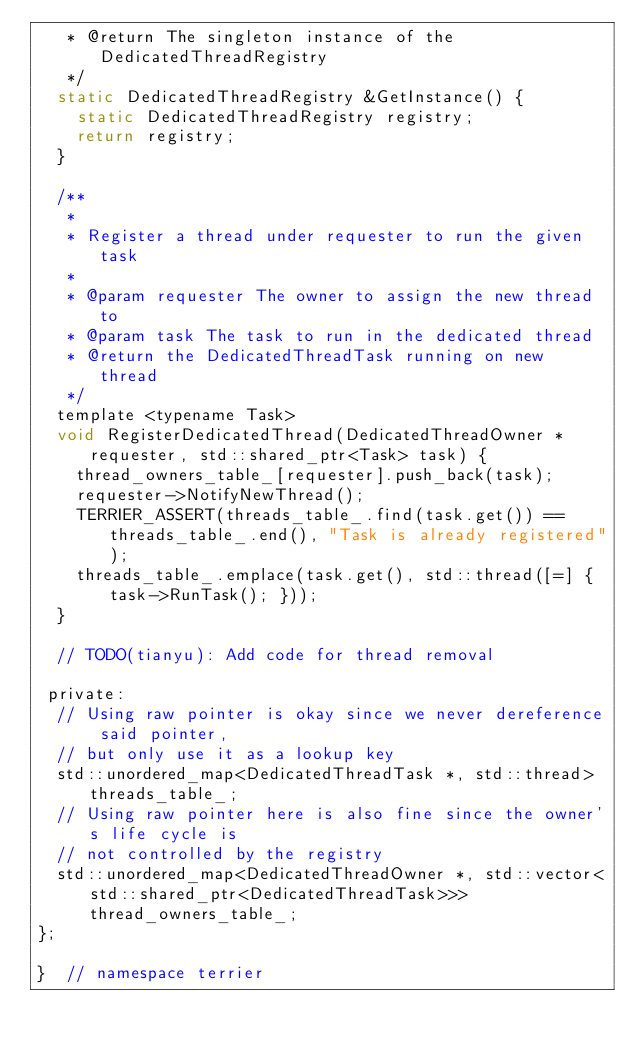Convert code to text. <code><loc_0><loc_0><loc_500><loc_500><_C_>   * @return The singleton instance of the DedicatedThreadRegistry
   */
  static DedicatedThreadRegistry &GetInstance() {
    static DedicatedThreadRegistry registry;
    return registry;
  }

  /**
   *
   * Register a thread under requester to run the given task
   *
   * @param requester The owner to assign the new thread to
   * @param task The task to run in the dedicated thread
   * @return the DedicatedThreadTask running on new thread
   */
  template <typename Task>
  void RegisterDedicatedThread(DedicatedThreadOwner *requester, std::shared_ptr<Task> task) {
    thread_owners_table_[requester].push_back(task);
    requester->NotifyNewThread();
    TERRIER_ASSERT(threads_table_.find(task.get()) == threads_table_.end(), "Task is already registered");
    threads_table_.emplace(task.get(), std::thread([=] { task->RunTask(); }));
  }

  // TODO(tianyu): Add code for thread removal

 private:
  // Using raw pointer is okay since we never dereference said pointer,
  // but only use it as a lookup key
  std::unordered_map<DedicatedThreadTask *, std::thread> threads_table_;
  // Using raw pointer here is also fine since the owner's life cycle is
  // not controlled by the registry
  std::unordered_map<DedicatedThreadOwner *, std::vector<std::shared_ptr<DedicatedThreadTask>>> thread_owners_table_;
};

}  // namespace terrier
</code> 